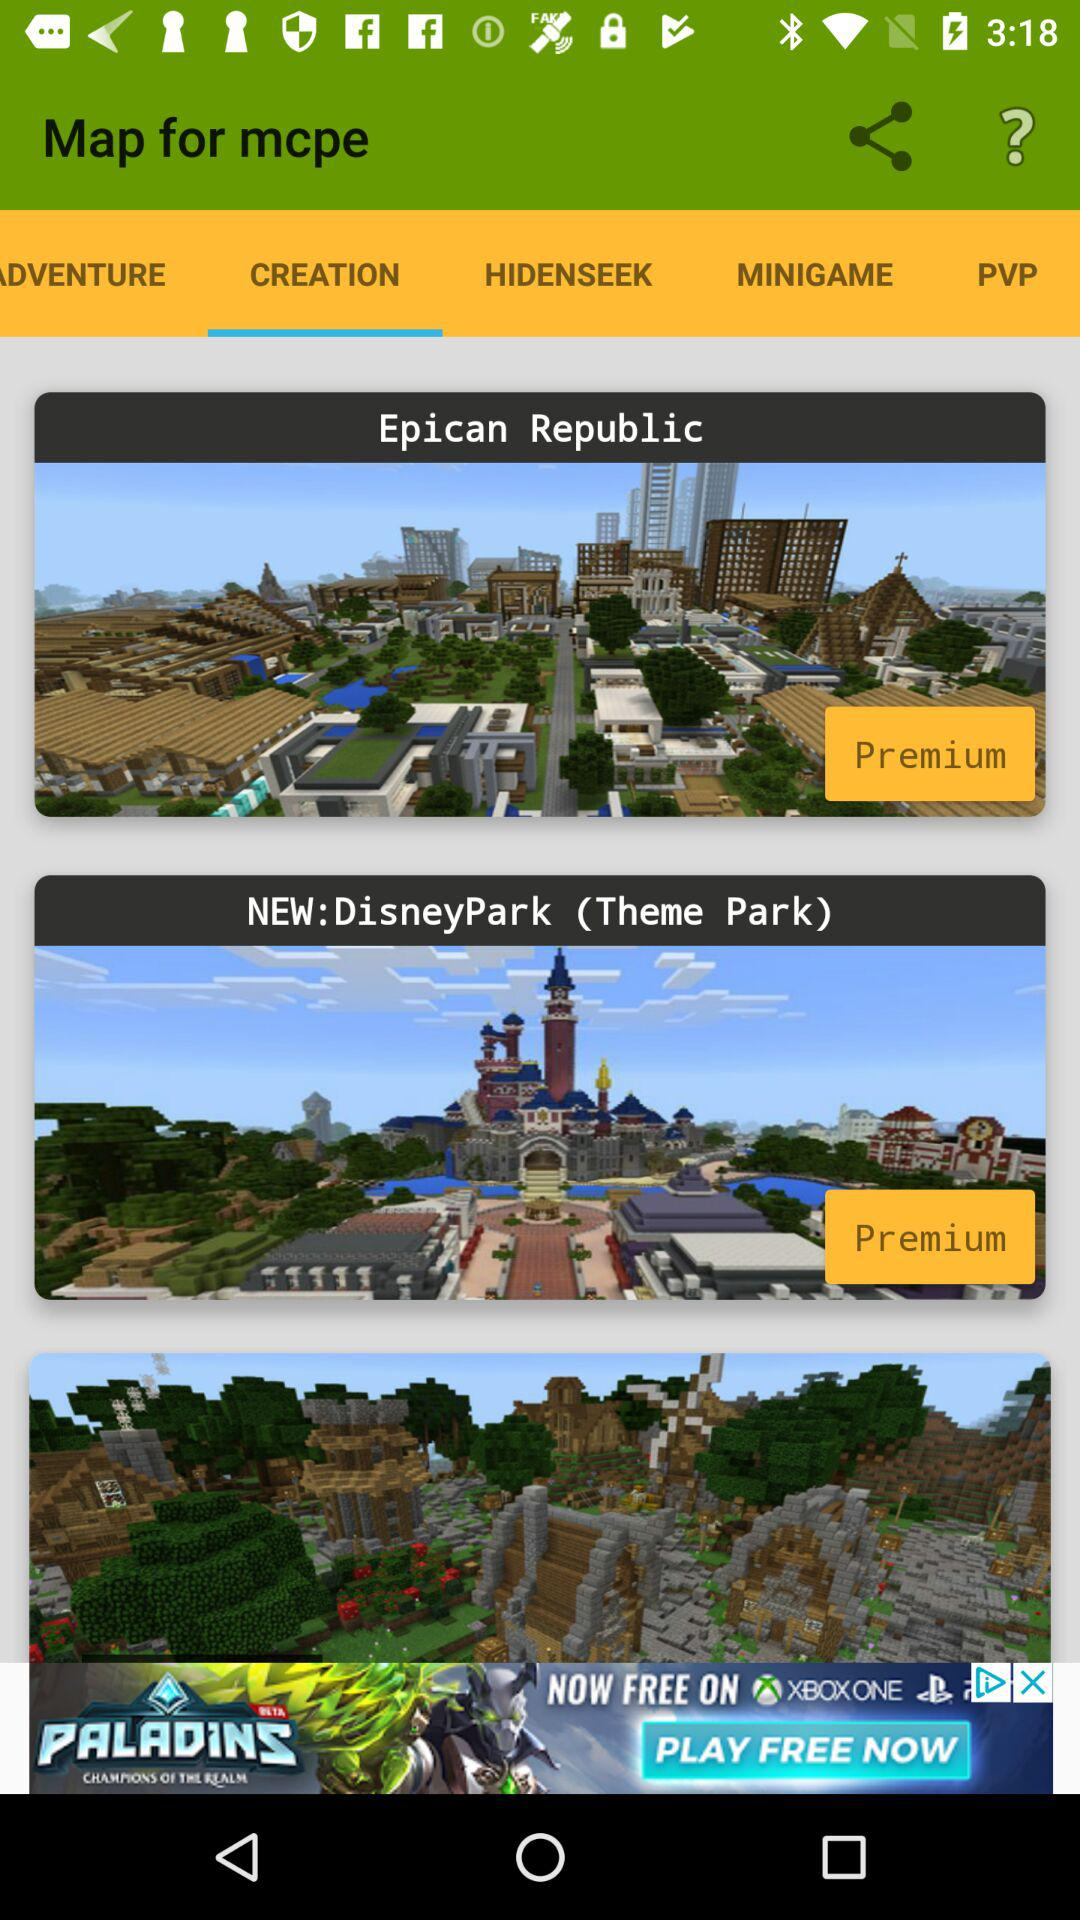How many premium maps are there?
Answer the question using a single word or phrase. 2 